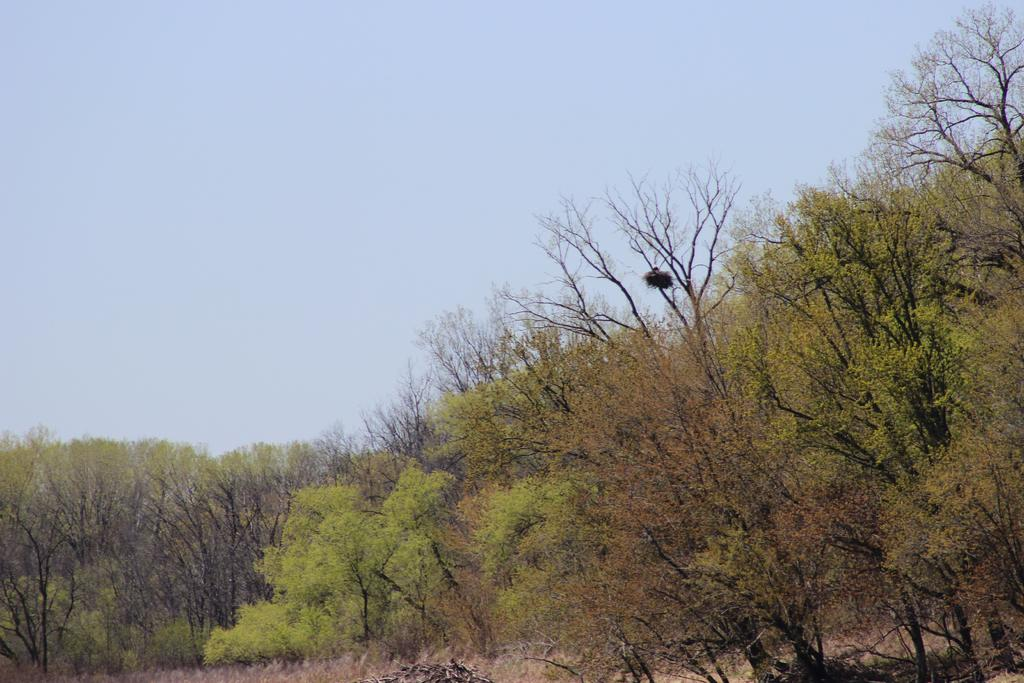What type of vegetation is present in the image? There are green trees in the image. What part of the natural environment is visible in the image? The sky is visible at the top of the image. What language is spoken by the trees in the image? Trees do not speak any language, so this question cannot be answered. 